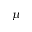<formula> <loc_0><loc_0><loc_500><loc_500>\mu</formula> 